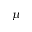<formula> <loc_0><loc_0><loc_500><loc_500>\mu</formula> 